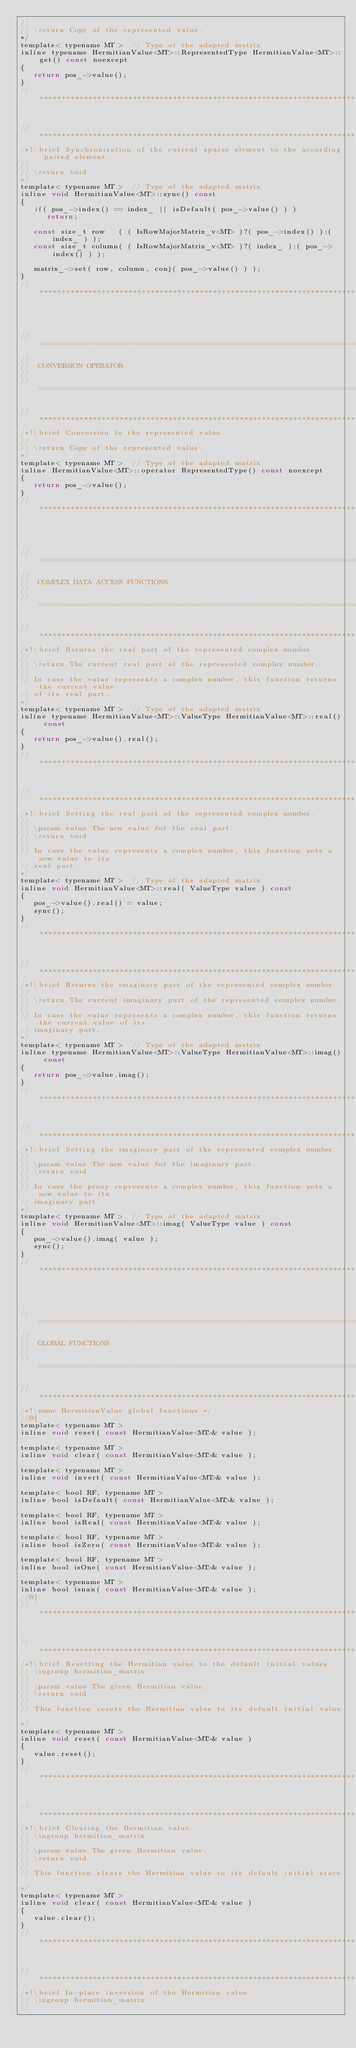<code> <loc_0><loc_0><loc_500><loc_500><_C_>//
// \return Copy of the represented value.
*/
template< typename MT >  // Type of the adapted matrix
inline typename HermitianValue<MT>::RepresentedType HermitianValue<MT>::get() const noexcept
{
   return pos_->value();
}
//*************************************************************************************************


//*************************************************************************************************
/*!\brief Synchronization of the current sparse element to the according paired element.
//
// \return void
*/
template< typename MT >  // Type of the adapted matrix
inline void HermitianValue<MT>::sync() const
{
   if( pos_->index() == index_ || isDefault( pos_->value() ) )
      return;

   const size_t row   ( ( IsRowMajorMatrix_v<MT> )?( pos_->index() ):( index_ ) );
   const size_t column( ( IsRowMajorMatrix_v<MT> )?( index_ ):( pos_->index() ) );

   matrix_->set( row, column, conj( pos_->value() ) );
}
//*************************************************************************************************




//=================================================================================================
//
//  CONVERSION OPERATOR
//
//=================================================================================================

//*************************************************************************************************
/*!\brief Conversion to the represented value.
//
// \return Copy of the represented value.
*/
template< typename MT >  // Type of the adapted matrix
inline HermitianValue<MT>::operator RepresentedType() const noexcept
{
   return pos_->value();
}
//*************************************************************************************************




//=================================================================================================
//
//  COMPLEX DATA ACCESS FUNCTIONS
//
//=================================================================================================

//*************************************************************************************************
/*!\brief Returns the real part of the represented complex number.
//
// \return The current real part of the represented complex number.
//
// In case the value represents a complex number, this function returns the current value
// of its real part.
*/
template< typename MT >  // Type of the adapted matrix
inline typename HermitianValue<MT>::ValueType HermitianValue<MT>::real() const
{
   return pos_->value().real();
}
//*************************************************************************************************


//*************************************************************************************************
/*!\brief Setting the real part of the represented complex number.
//
// \param value The new value for the real part.
// \return void
//
// In case the value represents a complex number, this function sets a new value to its
// real part.
*/
template< typename MT >  // Type of the adapted matrix
inline void HermitianValue<MT>::real( ValueType value ) const
{
   pos_->value().real() = value;
   sync();
}
//*************************************************************************************************


//*************************************************************************************************
/*!\brief Returns the imaginary part of the represented complex number.
//
// \return The current imaginary part of the represented complex number.
//
// In case the value represents a complex number, this function returns the current value of its
// imaginary part.
*/
template< typename MT >  // Type of the adapted matrix
inline typename HermitianValue<MT>::ValueType HermitianValue<MT>::imag() const
{
   return pos_->value.imag();
}
//*************************************************************************************************


//*************************************************************************************************
/*!\brief Setting the imaginary part of the represented complex number.
//
// \param value The new value for the imaginary part.
// \return void
//
// In case the proxy represents a complex number, this function sets a new value to its
// imaginary part.
*/
template< typename MT >  // Type of the adapted matrix
inline void HermitianValue<MT>::imag( ValueType value ) const
{
   pos_->value().imag( value );
   sync();
}
//*************************************************************************************************




//=================================================================================================
//
//  GLOBAL FUNCTIONS
//
//=================================================================================================

//*************************************************************************************************
/*!\name HermitianValue global functions */
//@{
template< typename MT >
inline void reset( const HermitianValue<MT>& value );

template< typename MT >
inline void clear( const HermitianValue<MT>& value );

template< typename MT >
inline void invert( const HermitianValue<MT>& value );

template< bool RF, typename MT >
inline bool isDefault( const HermitianValue<MT>& value );

template< bool RF, typename MT >
inline bool isReal( const HermitianValue<MT>& value );

template< bool RF, typename MT >
inline bool isZero( const HermitianValue<MT>& value );

template< bool RF, typename MT >
inline bool isOne( const HermitianValue<MT>& value );

template< typename MT >
inline bool isnan( const HermitianValue<MT>& value );
//@}
//*************************************************************************************************


//*************************************************************************************************
/*!\brief Resetting the Hermitian value to the default initial values.
// \ingroup hermitian_matrix
//
// \param value The given Hermitian value.
// \return void
//
// This function resets the Hermitian value to its default initial value.
*/
template< typename MT >
inline void reset( const HermitianValue<MT>& value )
{
   value.reset();
}
//*************************************************************************************************


//*************************************************************************************************
/*!\brief Clearing the Hermitian value.
// \ingroup hermitian_matrix
//
// \param value The given Hermitian value.
// \return void
//
// This function clears the Hermitian value to its default initial state.
*/
template< typename MT >
inline void clear( const HermitianValue<MT>& value )
{
   value.clear();
}
//*************************************************************************************************


//*************************************************************************************************
/*!\brief In-place inversion of the Hermitian value.
// \ingroup hermitian_matrix
//</code> 